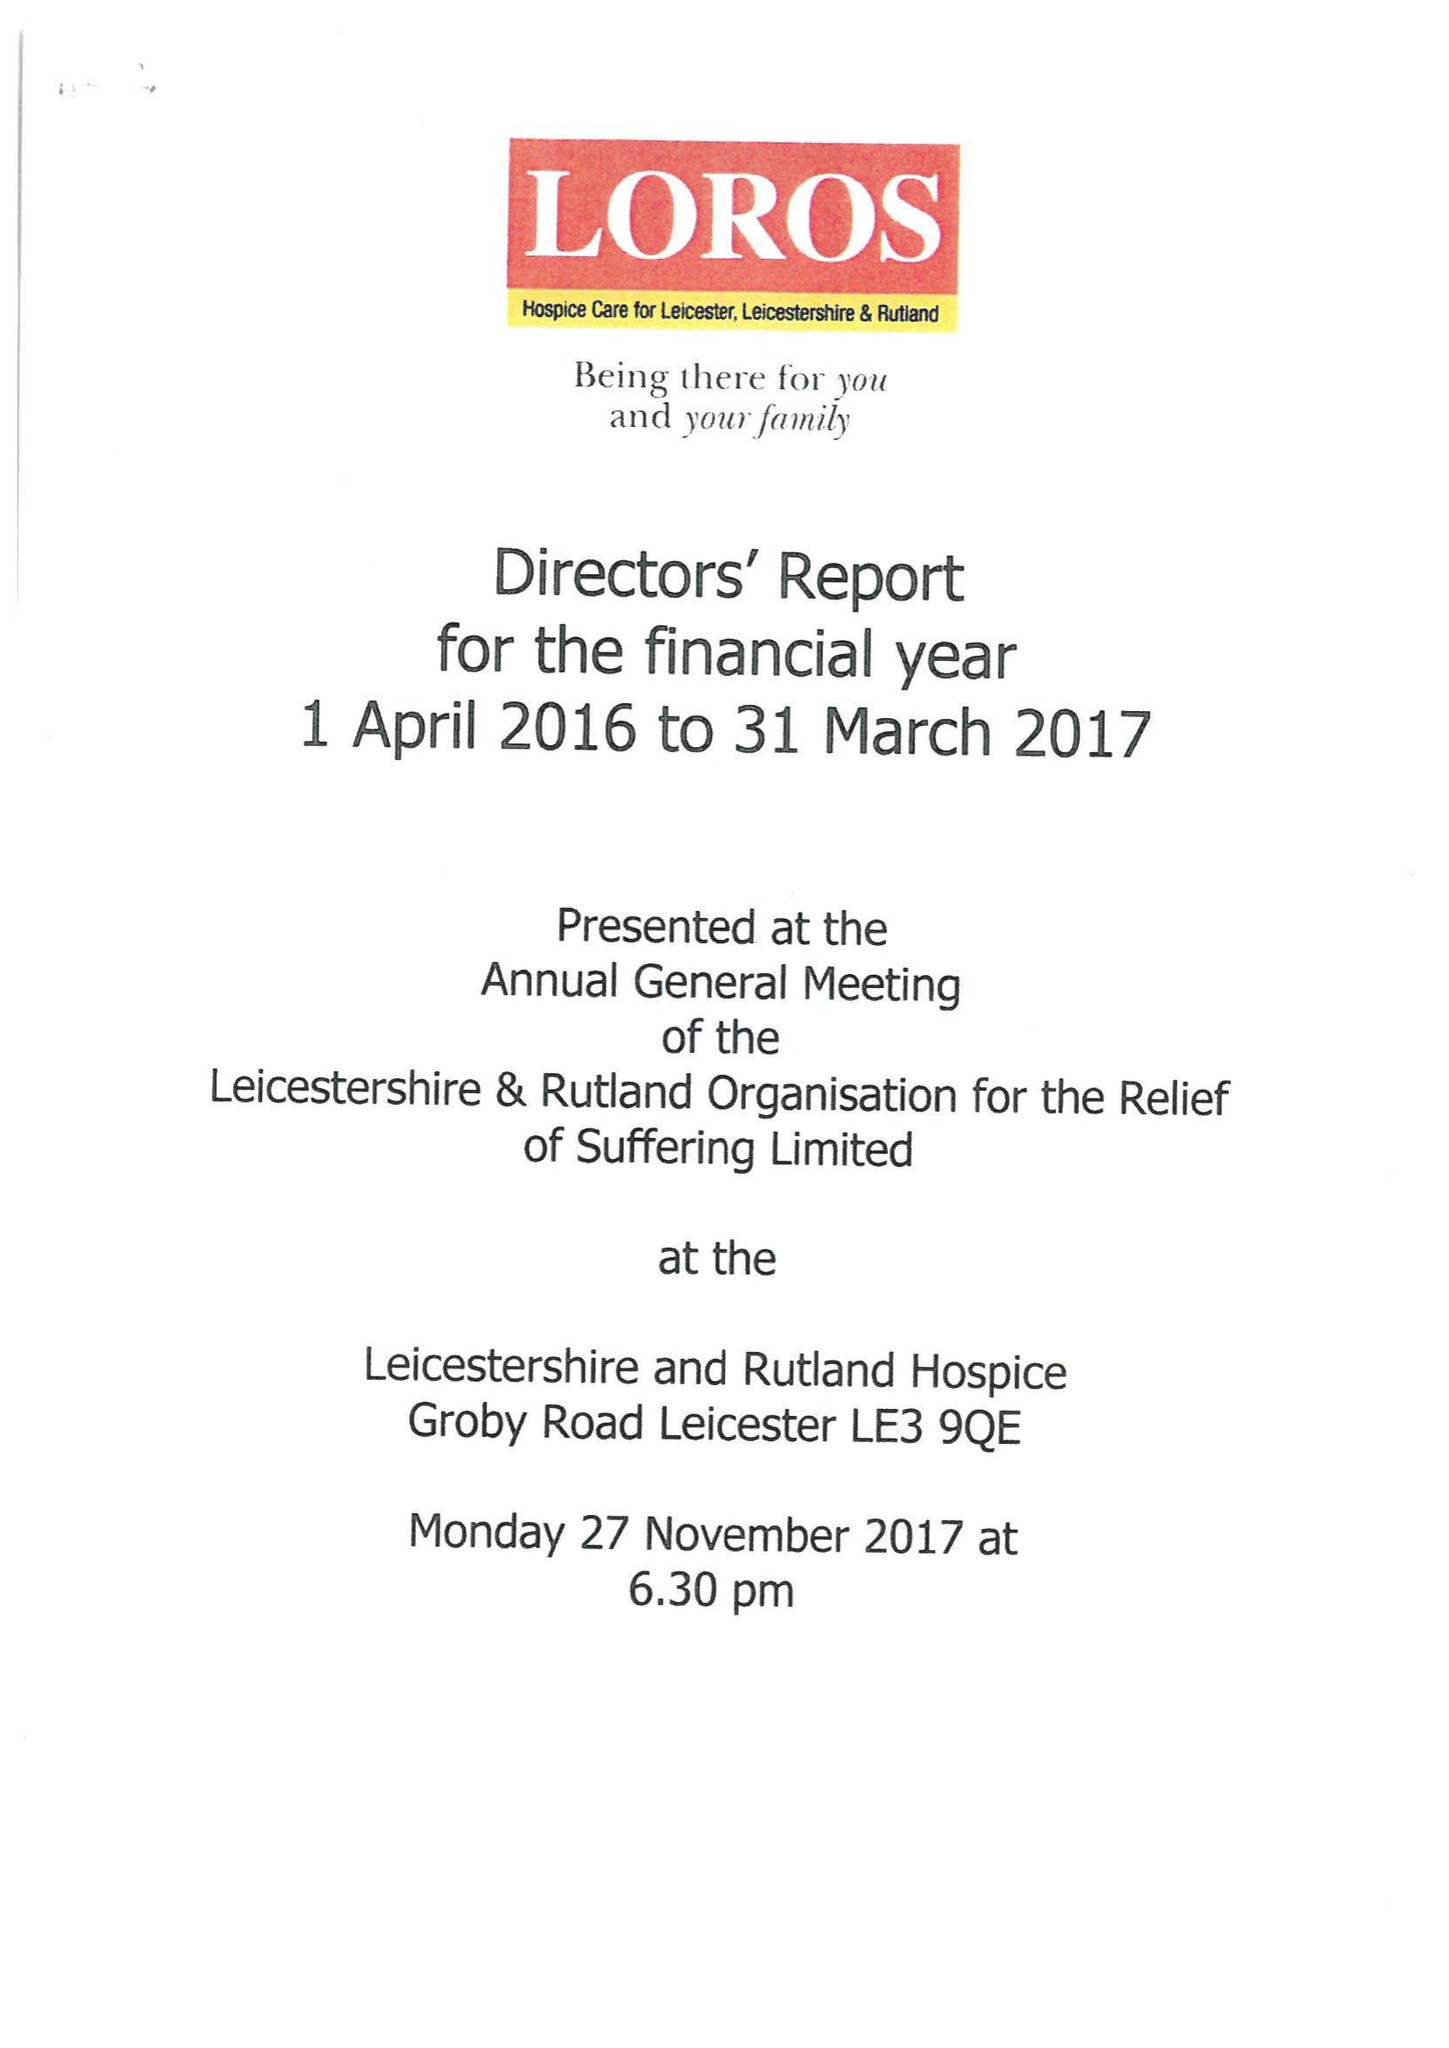What is the value for the income_annually_in_british_pounds?
Answer the question using a single word or phrase. 13032903.00 